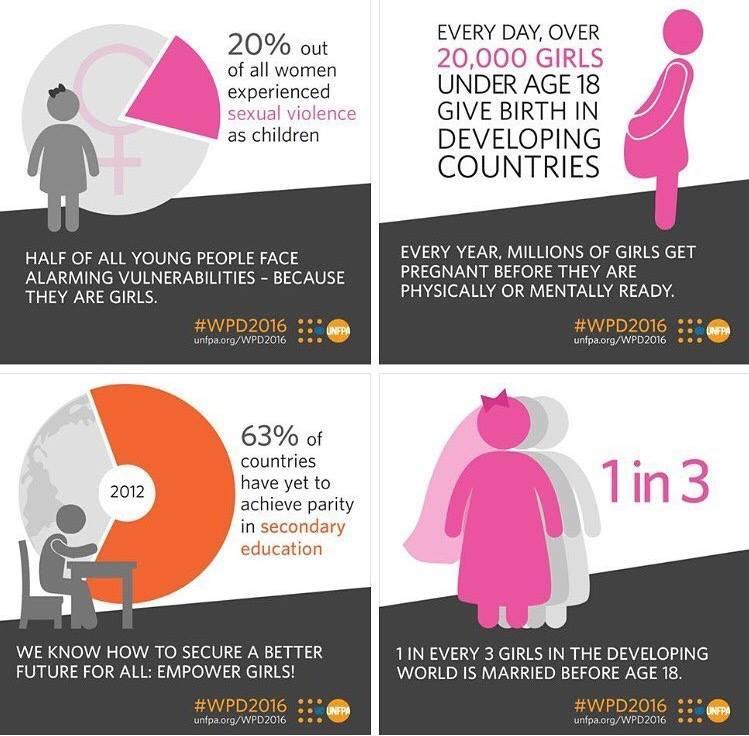in which country are 33% of the girls married before 18
Answer the question with a short phrase. developing what % of countries have achieved parity in secondary education 37 which year is mentioned in the pie chart 2012 By what age are girls physically and mentally ready to get pregnant 18 